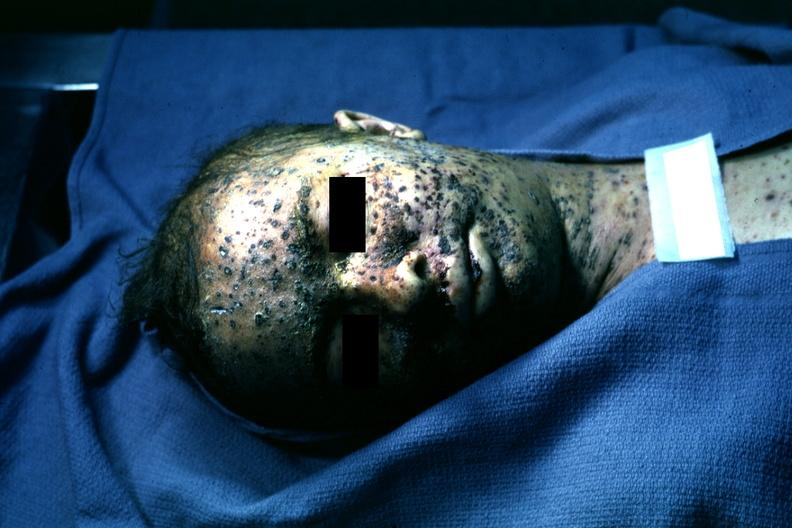s face present?
Answer the question using a single word or phrase. Yes 